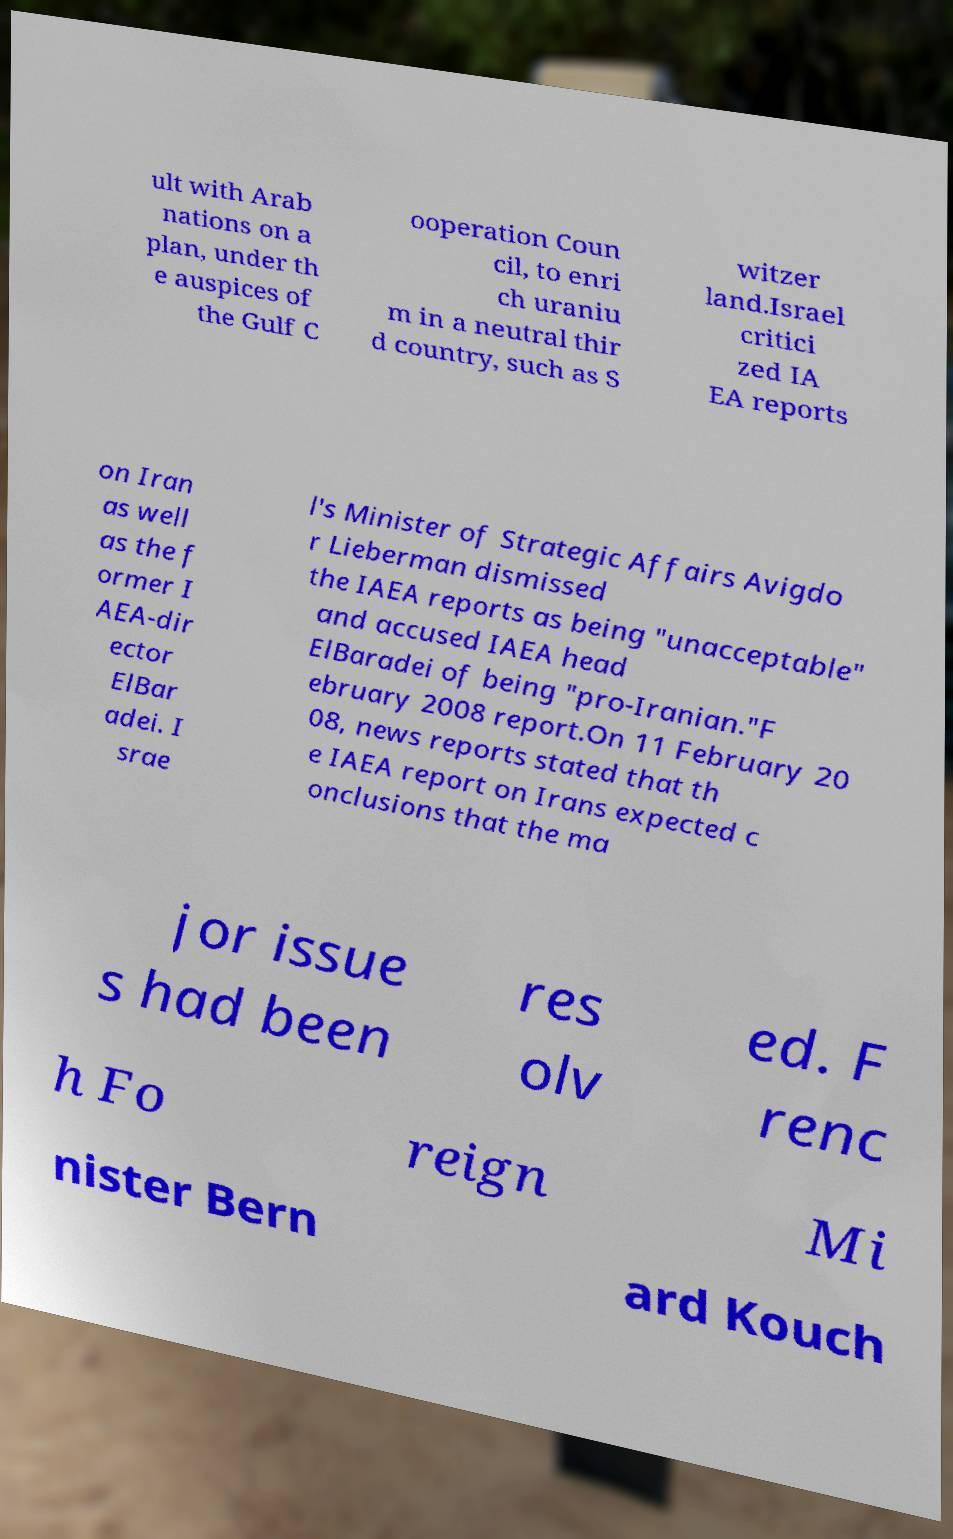Please identify and transcribe the text found in this image. ult with Arab nations on a plan, under th e auspices of the Gulf C ooperation Coun cil, to enri ch uraniu m in a neutral thir d country, such as S witzer land.Israel critici zed IA EA reports on Iran as well as the f ormer I AEA-dir ector ElBar adei. I srae l's Minister of Strategic Affairs Avigdo r Lieberman dismissed the IAEA reports as being "unacceptable" and accused IAEA head ElBaradei of being "pro-Iranian."F ebruary 2008 report.On 11 February 20 08, news reports stated that th e IAEA report on Irans expected c onclusions that the ma jor issue s had been res olv ed. F renc h Fo reign Mi nister Bern ard Kouch 